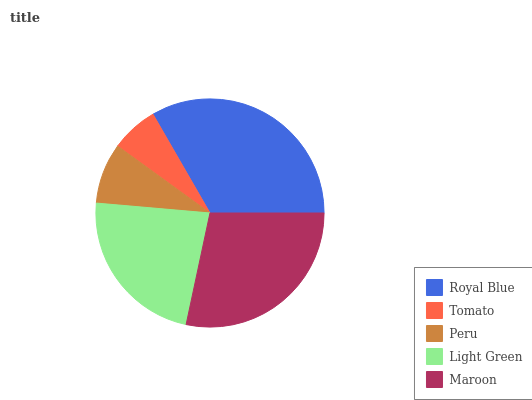Is Tomato the minimum?
Answer yes or no. Yes. Is Royal Blue the maximum?
Answer yes or no. Yes. Is Peru the minimum?
Answer yes or no. No. Is Peru the maximum?
Answer yes or no. No. Is Peru greater than Tomato?
Answer yes or no. Yes. Is Tomato less than Peru?
Answer yes or no. Yes. Is Tomato greater than Peru?
Answer yes or no. No. Is Peru less than Tomato?
Answer yes or no. No. Is Light Green the high median?
Answer yes or no. Yes. Is Light Green the low median?
Answer yes or no. Yes. Is Royal Blue the high median?
Answer yes or no. No. Is Maroon the low median?
Answer yes or no. No. 